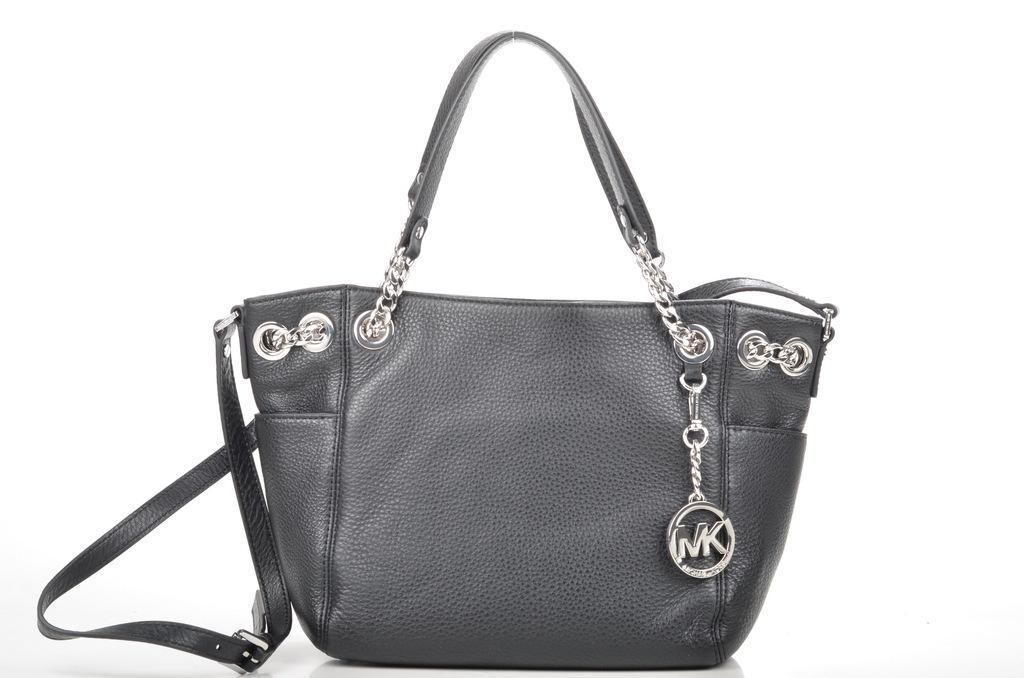What type of accessory is present in the image? There is a handbag in the image. Can you describe the color of the handbag? The handbag is in ash color. What word is written on the wrist of the person in the image? There is no person or wrist visible in the image; it only features a handbag. 